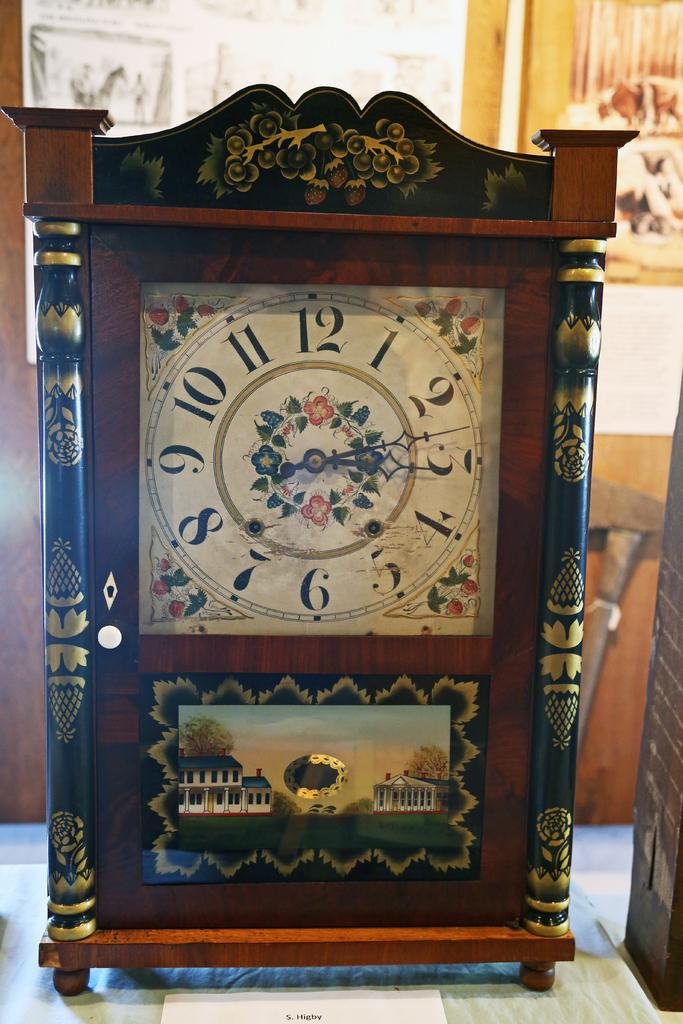Provide a one-sentence caption for the provided image. The hands of a decorative clock are arranged at about 13 minutes after 12. 